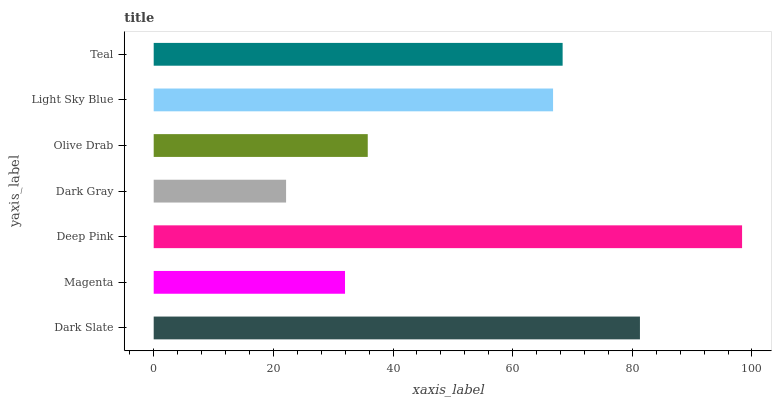Is Dark Gray the minimum?
Answer yes or no. Yes. Is Deep Pink the maximum?
Answer yes or no. Yes. Is Magenta the minimum?
Answer yes or no. No. Is Magenta the maximum?
Answer yes or no. No. Is Dark Slate greater than Magenta?
Answer yes or no. Yes. Is Magenta less than Dark Slate?
Answer yes or no. Yes. Is Magenta greater than Dark Slate?
Answer yes or no. No. Is Dark Slate less than Magenta?
Answer yes or no. No. Is Light Sky Blue the high median?
Answer yes or no. Yes. Is Light Sky Blue the low median?
Answer yes or no. Yes. Is Dark Slate the high median?
Answer yes or no. No. Is Deep Pink the low median?
Answer yes or no. No. 